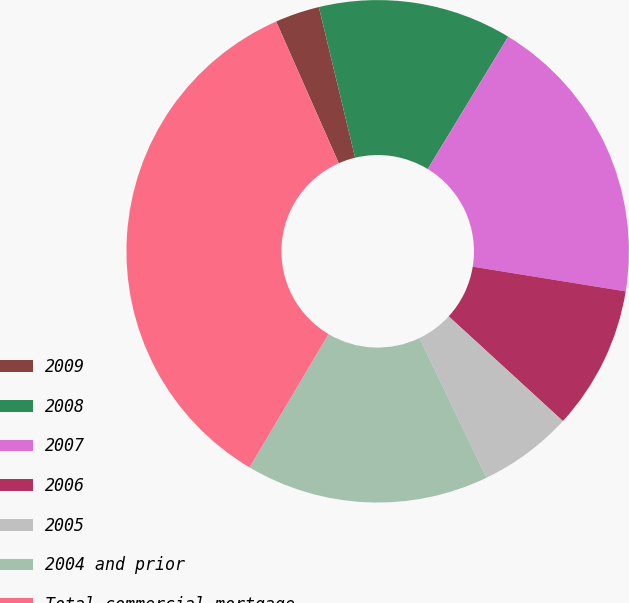Convert chart to OTSL. <chart><loc_0><loc_0><loc_500><loc_500><pie_chart><fcel>2009<fcel>2008<fcel>2007<fcel>2006<fcel>2005<fcel>2004 and prior<fcel>Total commercial mortgage<nl><fcel>2.86%<fcel>12.46%<fcel>18.86%<fcel>9.26%<fcel>6.06%<fcel>15.66%<fcel>34.86%<nl></chart> 